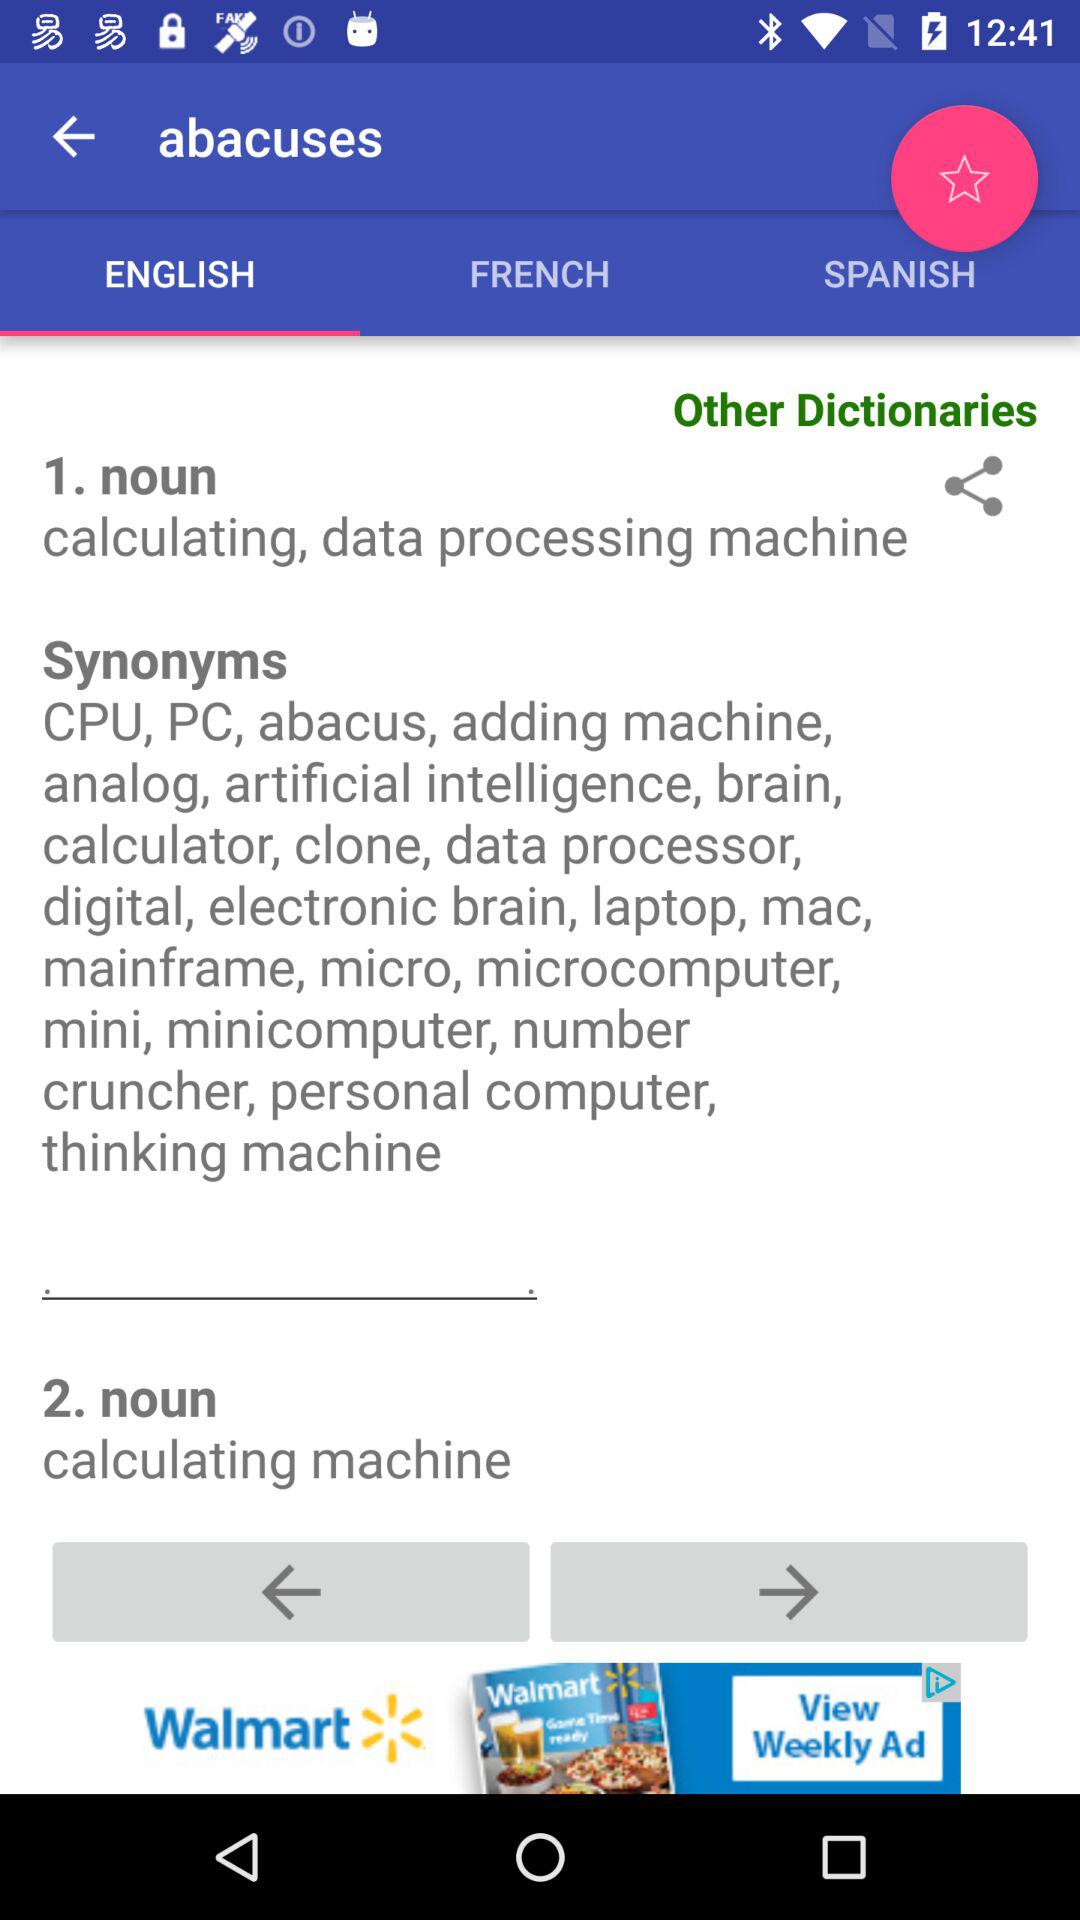What is the meaning of "abacuses" as a noun? The meanings of "abacuses" as a noun are calculating, data processing machine and calculating machine. 